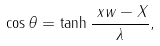<formula> <loc_0><loc_0><loc_500><loc_500>\cos \theta & = \tanh \frac { \ x w - X } { \lambda } ,</formula> 